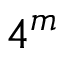<formula> <loc_0><loc_0><loc_500><loc_500>4 ^ { m }</formula> 